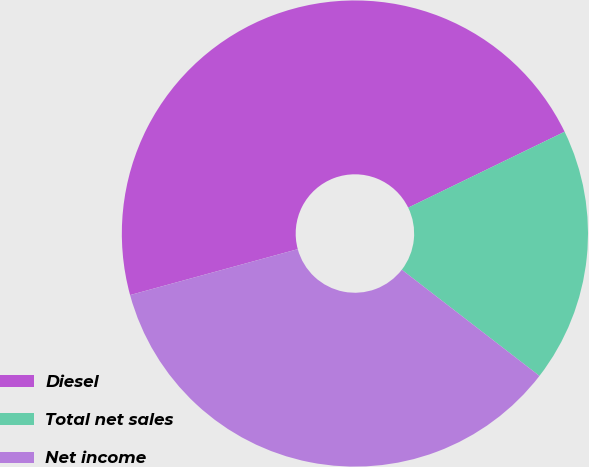Convert chart. <chart><loc_0><loc_0><loc_500><loc_500><pie_chart><fcel>Diesel<fcel>Total net sales<fcel>Net income<nl><fcel>47.06%<fcel>17.65%<fcel>35.29%<nl></chart> 